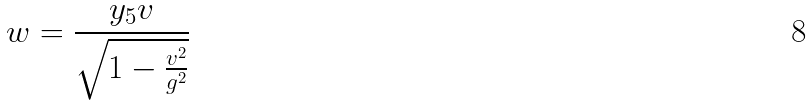Convert formula to latex. <formula><loc_0><loc_0><loc_500><loc_500>w = \frac { y _ { 5 } v } { \sqrt { 1 - \frac { v ^ { 2 } } { g ^ { 2 } } } }</formula> 